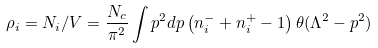Convert formula to latex. <formula><loc_0><loc_0><loc_500><loc_500>\rho _ { i } = N _ { i } / V = \frac { N _ { c } } { \pi ^ { 2 } } \int p ^ { 2 } d p \left ( n ^ { - } _ { i } + n ^ { + } _ { i } - 1 \right ) \theta ( \Lambda ^ { 2 } - p ^ { 2 } )</formula> 